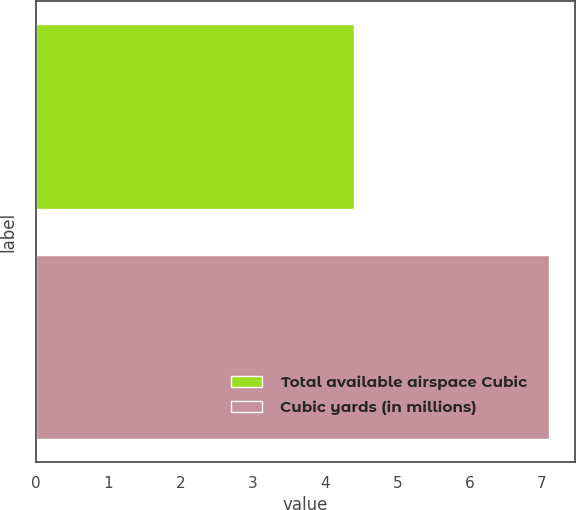Convert chart to OTSL. <chart><loc_0><loc_0><loc_500><loc_500><bar_chart><fcel>Total available airspace Cubic<fcel>Cubic yards (in millions)<nl><fcel>4.4<fcel>7.1<nl></chart> 